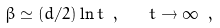Convert formula to latex. <formula><loc_0><loc_0><loc_500><loc_500>\beta \simeq ( d / 2 ) \ln t \ , \quad t \to \infty \ ,</formula> 